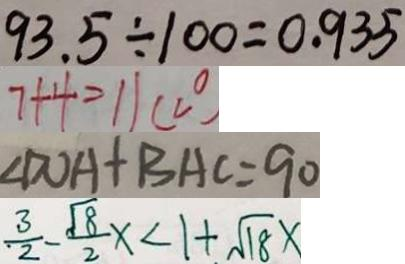<formula> <loc_0><loc_0><loc_500><loc_500>9 3 . 5 \div 1 0 0 = 0 . 9 3 5 
 7 + 4 = 1 1 ( c ^ { \circ } ) 
 \angle D O A + B A C = 9 0 
 \frac { 3 } { 2 } - \frac { \sqrt { 8 } } { 2 } x < 1 + \sqrt { 1 8 } x</formula> 